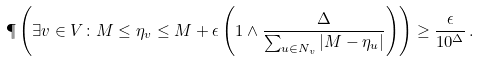Convert formula to latex. <formula><loc_0><loc_0><loc_500><loc_500>\P \left ( \exists v \in V \colon M \leq \eta _ { v } \leq M + \epsilon \left ( 1 \wedge \frac { \Delta } { \sum _ { u \in N _ { v } } | M - \eta _ { u } | } \right ) \right ) \geq \frac { \epsilon } { 1 0 ^ { \Delta } } \, .</formula> 